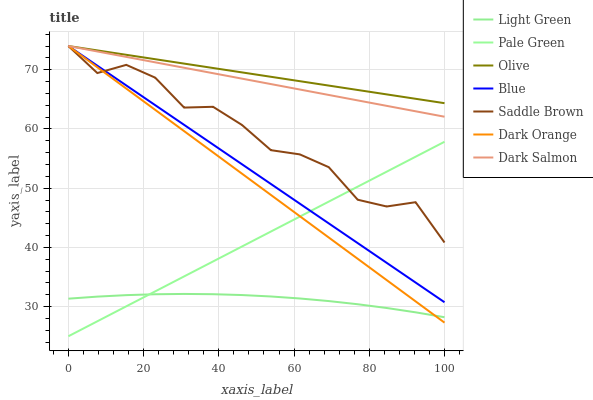Does Light Green have the minimum area under the curve?
Answer yes or no. Yes. Does Olive have the maximum area under the curve?
Answer yes or no. Yes. Does Dark Orange have the minimum area under the curve?
Answer yes or no. No. Does Dark Orange have the maximum area under the curve?
Answer yes or no. No. Is Dark Salmon the smoothest?
Answer yes or no. Yes. Is Saddle Brown the roughest?
Answer yes or no. Yes. Is Dark Orange the smoothest?
Answer yes or no. No. Is Dark Orange the roughest?
Answer yes or no. No. Does Pale Green have the lowest value?
Answer yes or no. Yes. Does Dark Orange have the lowest value?
Answer yes or no. No. Does Saddle Brown have the highest value?
Answer yes or no. Yes. Does Pale Green have the highest value?
Answer yes or no. No. Is Light Green less than Olive?
Answer yes or no. Yes. Is Dark Salmon greater than Pale Green?
Answer yes or no. Yes. Does Dark Orange intersect Dark Salmon?
Answer yes or no. Yes. Is Dark Orange less than Dark Salmon?
Answer yes or no. No. Is Dark Orange greater than Dark Salmon?
Answer yes or no. No. Does Light Green intersect Olive?
Answer yes or no. No. 